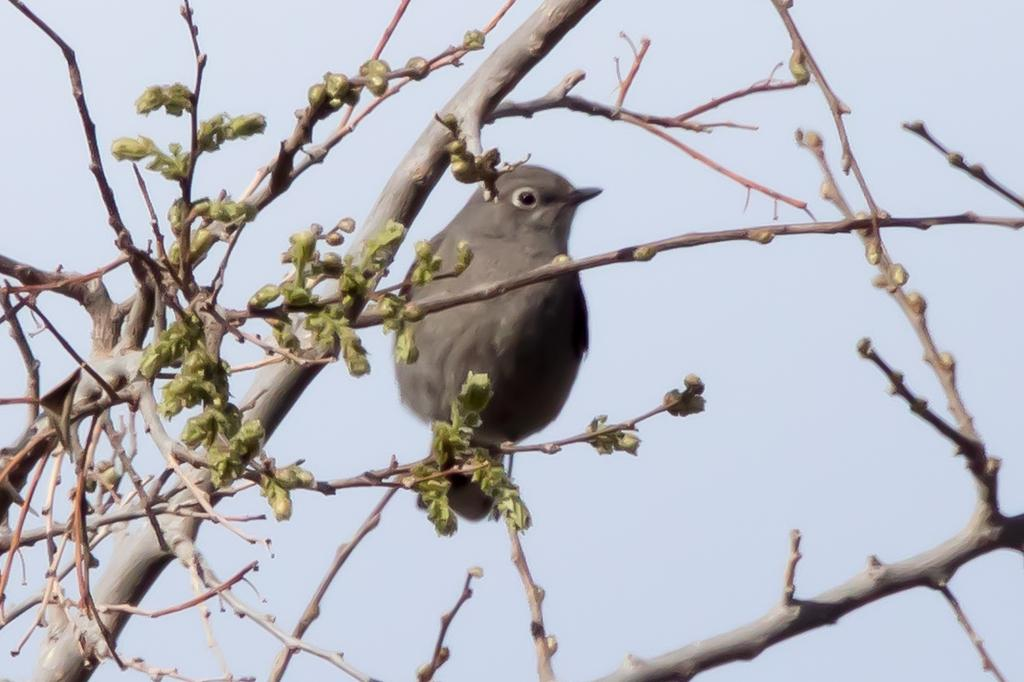What is the main subject in the center of the image? There is a tree in the center of the image. What is sitting on the tree in the image? There is a bird sitting on a branch of the tree. Can you describe the bird's appearance? The bird is ash-colored. What can be seen in the background of the image? The sky is visible in the background of the image. What type of manager is overseeing the snakes in the image? There are no snakes or managers present in the image; it features a tree with a bird on a branch. 